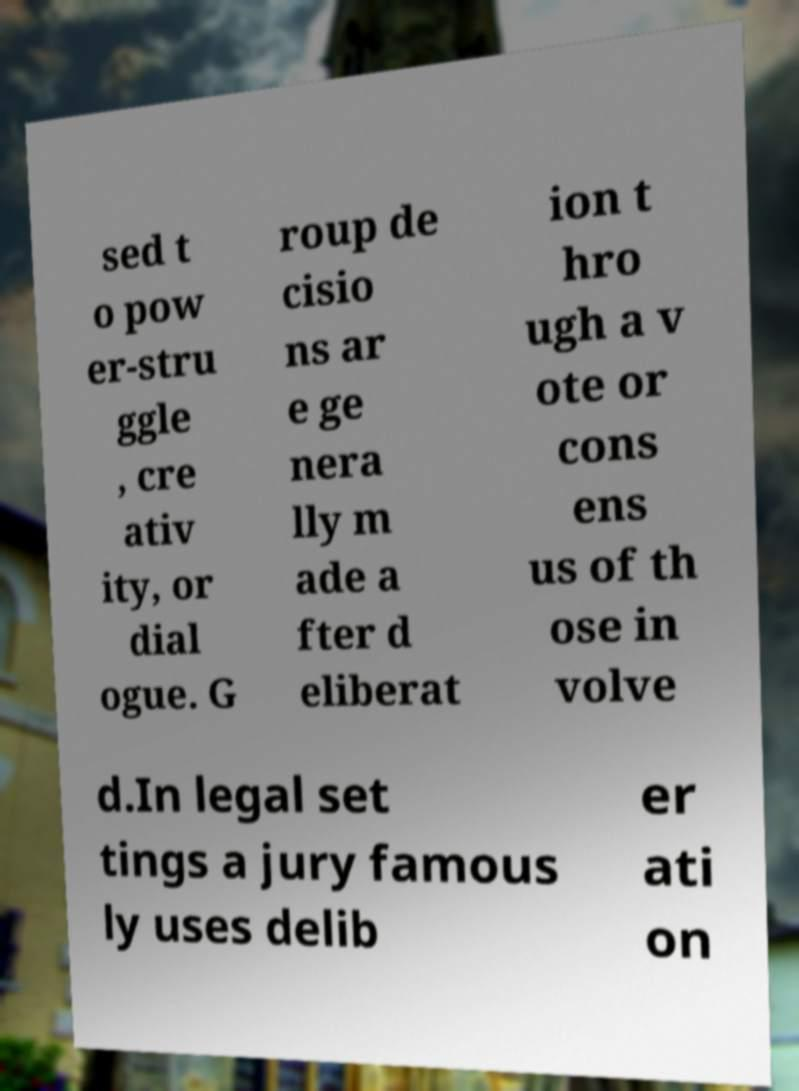Can you accurately transcribe the text from the provided image for me? sed t o pow er-stru ggle , cre ativ ity, or dial ogue. G roup de cisio ns ar e ge nera lly m ade a fter d eliberat ion t hro ugh a v ote or cons ens us of th ose in volve d.In legal set tings a jury famous ly uses delib er ati on 